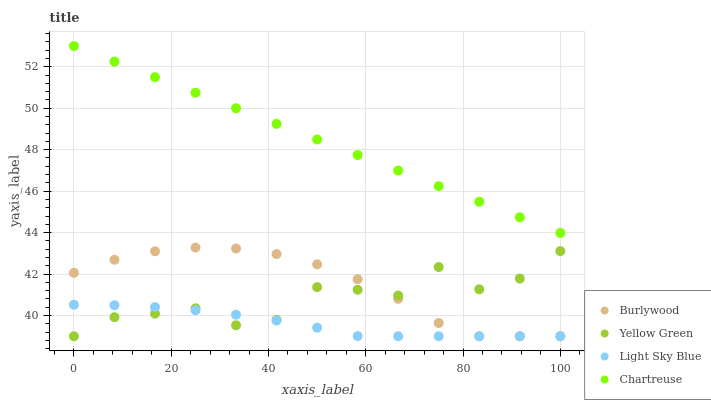Does Light Sky Blue have the minimum area under the curve?
Answer yes or no. Yes. Does Chartreuse have the maximum area under the curve?
Answer yes or no. Yes. Does Chartreuse have the minimum area under the curve?
Answer yes or no. No. Does Light Sky Blue have the maximum area under the curve?
Answer yes or no. No. Is Chartreuse the smoothest?
Answer yes or no. Yes. Is Yellow Green the roughest?
Answer yes or no. Yes. Is Light Sky Blue the smoothest?
Answer yes or no. No. Is Light Sky Blue the roughest?
Answer yes or no. No. Does Burlywood have the lowest value?
Answer yes or no. Yes. Does Chartreuse have the lowest value?
Answer yes or no. No. Does Chartreuse have the highest value?
Answer yes or no. Yes. Does Light Sky Blue have the highest value?
Answer yes or no. No. Is Light Sky Blue less than Chartreuse?
Answer yes or no. Yes. Is Chartreuse greater than Light Sky Blue?
Answer yes or no. Yes. Does Yellow Green intersect Burlywood?
Answer yes or no. Yes. Is Yellow Green less than Burlywood?
Answer yes or no. No. Is Yellow Green greater than Burlywood?
Answer yes or no. No. Does Light Sky Blue intersect Chartreuse?
Answer yes or no. No. 